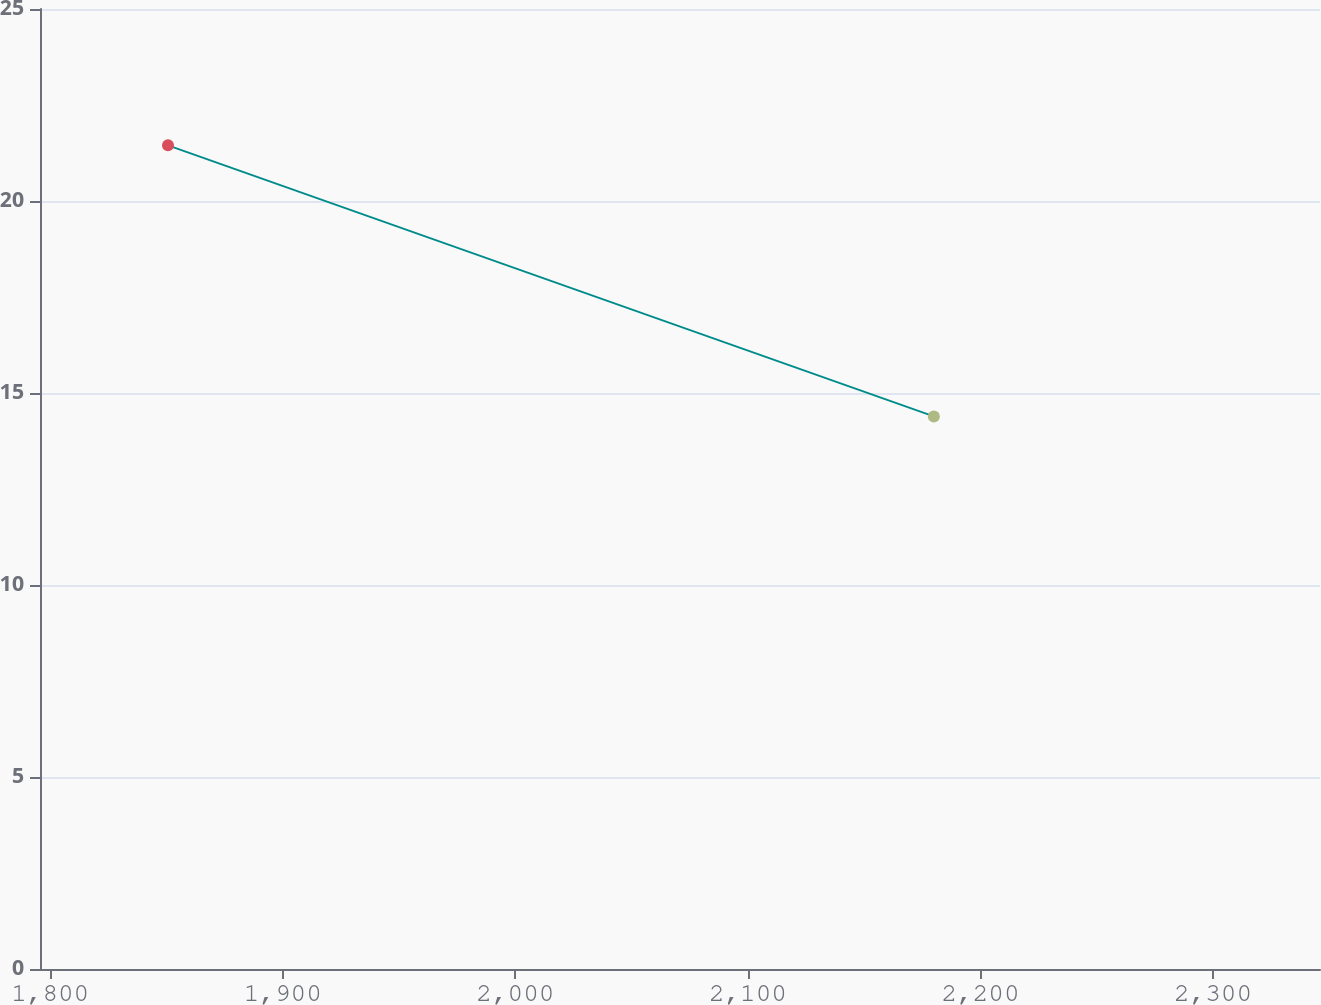<chart> <loc_0><loc_0><loc_500><loc_500><line_chart><ecel><fcel>$ 28.3<nl><fcel>1850.66<fcel>21.45<nl><fcel>2179.94<fcel>14.39<nl><fcel>2346.16<fcel>11.25<nl><fcel>2401.01<fcel>12.63<nl></chart> 